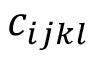Convert formula to latex. <formula><loc_0><loc_0><loc_500><loc_500>c _ { i j k l }</formula> 